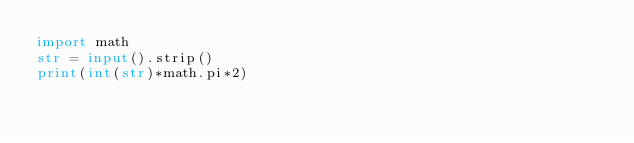<code> <loc_0><loc_0><loc_500><loc_500><_Python_>import math 
str = input().strip()
print(int(str)*math.pi*2)</code> 